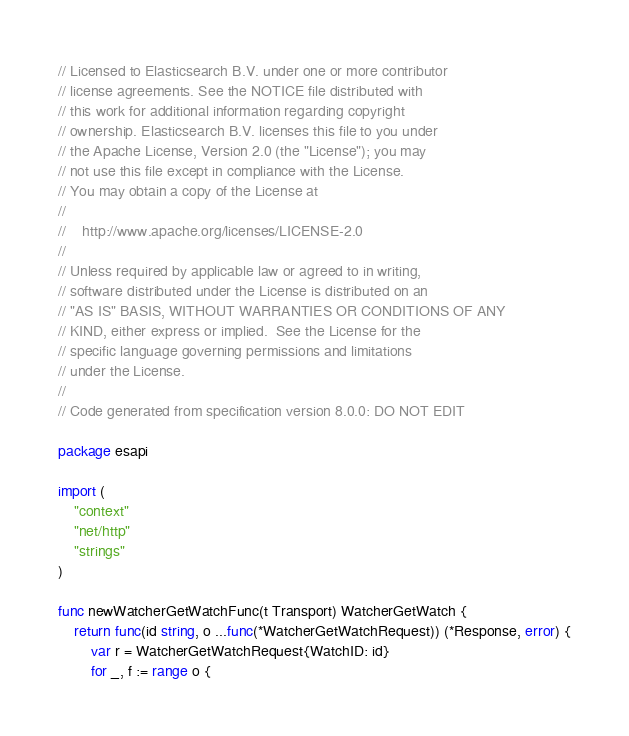<code> <loc_0><loc_0><loc_500><loc_500><_Go_>// Licensed to Elasticsearch B.V. under one or more contributor
// license agreements. See the NOTICE file distributed with
// this work for additional information regarding copyright
// ownership. Elasticsearch B.V. licenses this file to you under
// the Apache License, Version 2.0 (the "License"); you may
// not use this file except in compliance with the License.
// You may obtain a copy of the License at
//
//    http://www.apache.org/licenses/LICENSE-2.0
//
// Unless required by applicable law or agreed to in writing,
// software distributed under the License is distributed on an
// "AS IS" BASIS, WITHOUT WARRANTIES OR CONDITIONS OF ANY
// KIND, either express or implied.  See the License for the
// specific language governing permissions and limitations
// under the License.
//
// Code generated from specification version 8.0.0: DO NOT EDIT

package esapi

import (
	"context"
	"net/http"
	"strings"
)

func newWatcherGetWatchFunc(t Transport) WatcherGetWatch {
	return func(id string, o ...func(*WatcherGetWatchRequest)) (*Response, error) {
		var r = WatcherGetWatchRequest{WatchID: id}
		for _, f := range o {</code> 